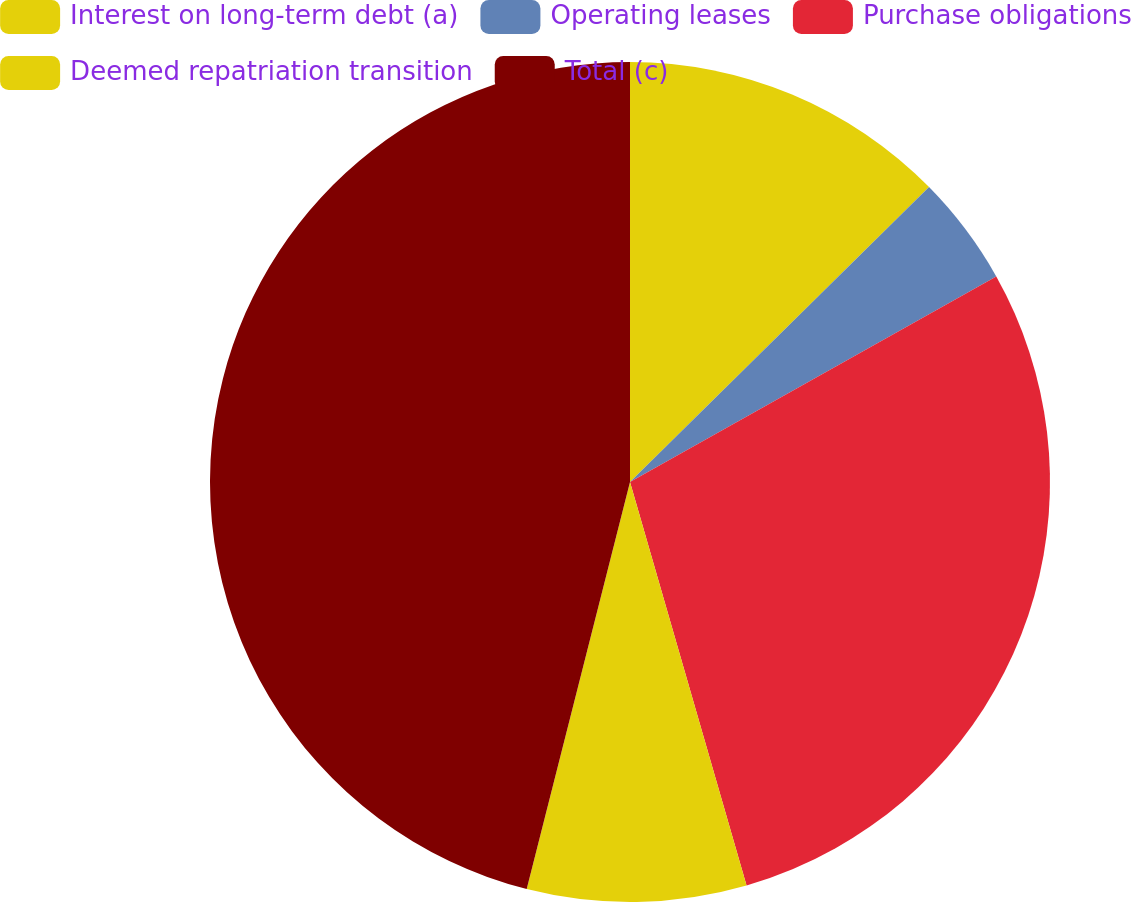<chart> <loc_0><loc_0><loc_500><loc_500><pie_chart><fcel>Interest on long-term debt (a)<fcel>Operating leases<fcel>Purchase obligations<fcel>Deemed repatriation transition<fcel>Total (c)<nl><fcel>12.61%<fcel>4.25%<fcel>28.66%<fcel>8.43%<fcel>46.04%<nl></chart> 